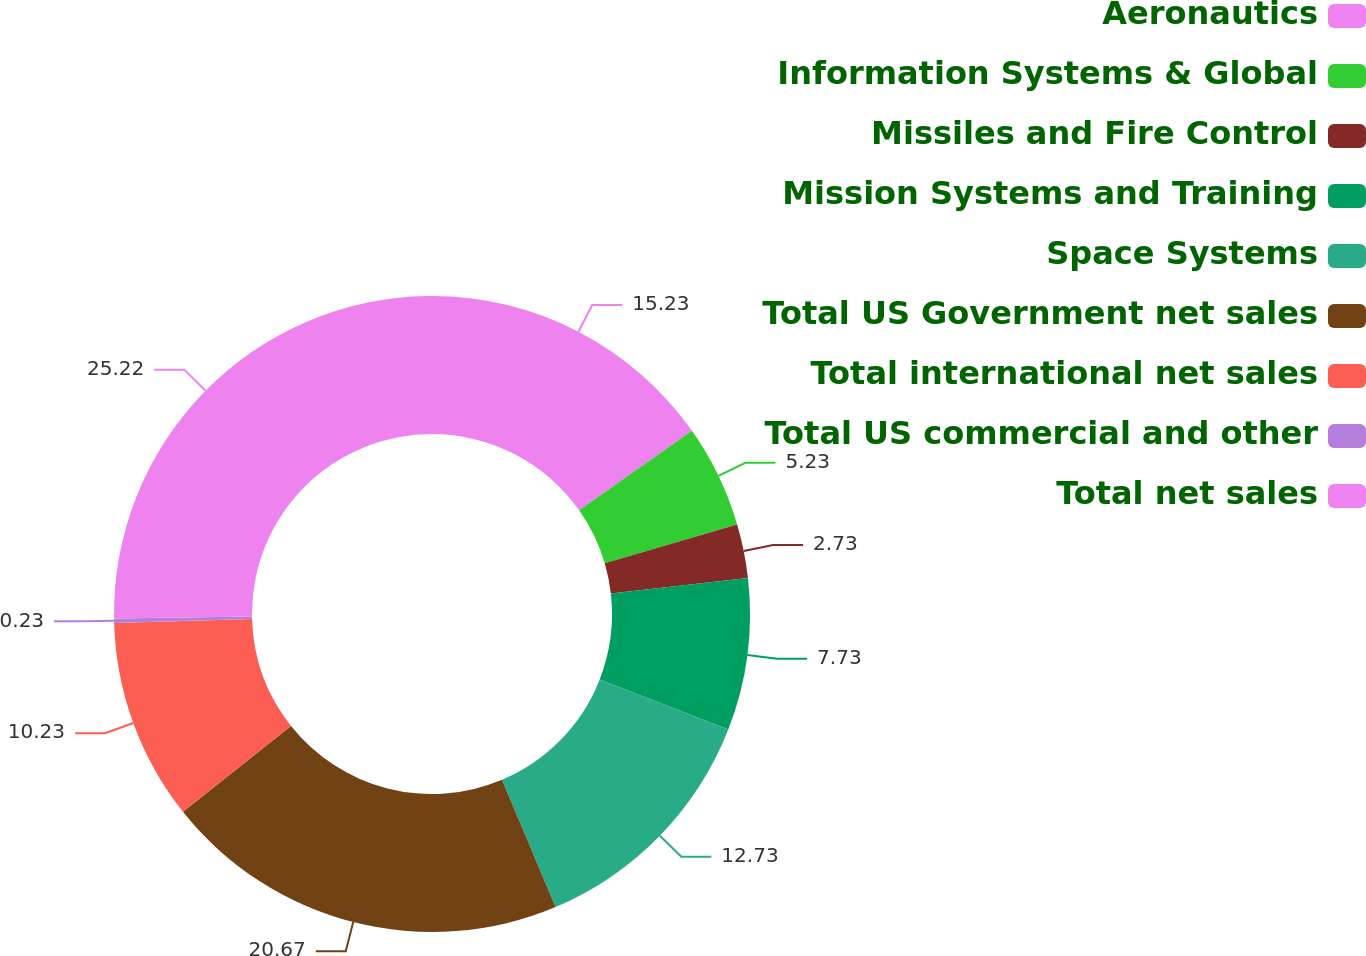Convert chart. <chart><loc_0><loc_0><loc_500><loc_500><pie_chart><fcel>Aeronautics<fcel>Information Systems & Global<fcel>Missiles and Fire Control<fcel>Mission Systems and Training<fcel>Space Systems<fcel>Total US Government net sales<fcel>Total international net sales<fcel>Total US commercial and other<fcel>Total net sales<nl><fcel>15.23%<fcel>5.23%<fcel>2.73%<fcel>7.73%<fcel>12.73%<fcel>20.67%<fcel>10.23%<fcel>0.23%<fcel>25.22%<nl></chart> 